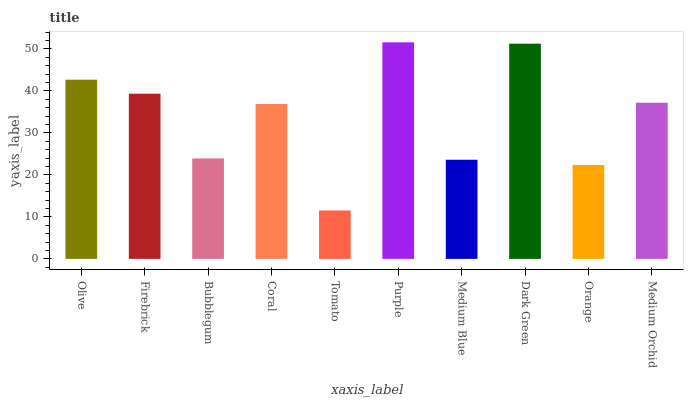Is Tomato the minimum?
Answer yes or no. Yes. Is Purple the maximum?
Answer yes or no. Yes. Is Firebrick the minimum?
Answer yes or no. No. Is Firebrick the maximum?
Answer yes or no. No. Is Olive greater than Firebrick?
Answer yes or no. Yes. Is Firebrick less than Olive?
Answer yes or no. Yes. Is Firebrick greater than Olive?
Answer yes or no. No. Is Olive less than Firebrick?
Answer yes or no. No. Is Medium Orchid the high median?
Answer yes or no. Yes. Is Coral the low median?
Answer yes or no. Yes. Is Dark Green the high median?
Answer yes or no. No. Is Medium Blue the low median?
Answer yes or no. No. 